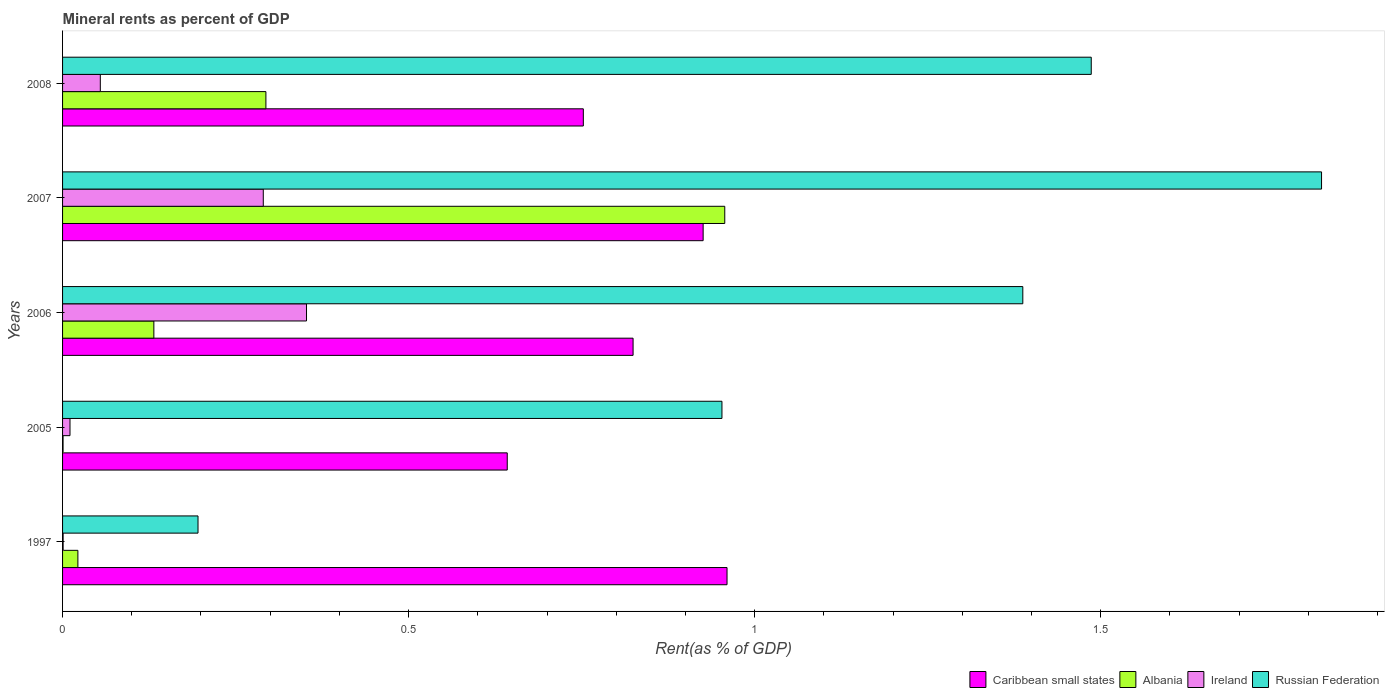How many different coloured bars are there?
Offer a very short reply. 4. How many groups of bars are there?
Give a very brief answer. 5. Are the number of bars per tick equal to the number of legend labels?
Provide a succinct answer. Yes. What is the mineral rent in Caribbean small states in 1997?
Offer a terse response. 0.96. Across all years, what is the maximum mineral rent in Ireland?
Offer a terse response. 0.35. Across all years, what is the minimum mineral rent in Albania?
Ensure brevity in your answer.  0. In which year was the mineral rent in Ireland minimum?
Make the answer very short. 1997. What is the total mineral rent in Caribbean small states in the graph?
Provide a succinct answer. 4.11. What is the difference between the mineral rent in Albania in 1997 and that in 2007?
Provide a short and direct response. -0.93. What is the difference between the mineral rent in Caribbean small states in 2006 and the mineral rent in Albania in 2007?
Make the answer very short. -0.13. What is the average mineral rent in Caribbean small states per year?
Provide a short and direct response. 0.82. In the year 2008, what is the difference between the mineral rent in Russian Federation and mineral rent in Albania?
Make the answer very short. 1.19. What is the ratio of the mineral rent in Ireland in 1997 to that in 2006?
Offer a very short reply. 0. Is the difference between the mineral rent in Russian Federation in 2005 and 2008 greater than the difference between the mineral rent in Albania in 2005 and 2008?
Provide a succinct answer. No. What is the difference between the highest and the second highest mineral rent in Albania?
Keep it short and to the point. 0.66. What is the difference between the highest and the lowest mineral rent in Albania?
Offer a terse response. 0.96. Is the sum of the mineral rent in Caribbean small states in 2005 and 2008 greater than the maximum mineral rent in Ireland across all years?
Your answer should be compact. Yes. Is it the case that in every year, the sum of the mineral rent in Russian Federation and mineral rent in Albania is greater than the sum of mineral rent in Caribbean small states and mineral rent in Ireland?
Offer a very short reply. No. What does the 4th bar from the top in 2008 represents?
Make the answer very short. Caribbean small states. What does the 4th bar from the bottom in 2007 represents?
Offer a very short reply. Russian Federation. What is the difference between two consecutive major ticks on the X-axis?
Ensure brevity in your answer.  0.5. How are the legend labels stacked?
Offer a terse response. Horizontal. What is the title of the graph?
Keep it short and to the point. Mineral rents as percent of GDP. What is the label or title of the X-axis?
Give a very brief answer. Rent(as % of GDP). What is the label or title of the Y-axis?
Your answer should be compact. Years. What is the Rent(as % of GDP) in Caribbean small states in 1997?
Your answer should be very brief. 0.96. What is the Rent(as % of GDP) of Albania in 1997?
Provide a short and direct response. 0.02. What is the Rent(as % of GDP) in Ireland in 1997?
Offer a terse response. 0. What is the Rent(as % of GDP) in Russian Federation in 1997?
Give a very brief answer. 0.2. What is the Rent(as % of GDP) in Caribbean small states in 2005?
Ensure brevity in your answer.  0.64. What is the Rent(as % of GDP) in Albania in 2005?
Offer a terse response. 0. What is the Rent(as % of GDP) in Ireland in 2005?
Your answer should be very brief. 0.01. What is the Rent(as % of GDP) of Russian Federation in 2005?
Your answer should be very brief. 0.95. What is the Rent(as % of GDP) in Caribbean small states in 2006?
Ensure brevity in your answer.  0.82. What is the Rent(as % of GDP) of Albania in 2006?
Provide a succinct answer. 0.13. What is the Rent(as % of GDP) of Ireland in 2006?
Your response must be concise. 0.35. What is the Rent(as % of GDP) in Russian Federation in 2006?
Your answer should be compact. 1.39. What is the Rent(as % of GDP) of Caribbean small states in 2007?
Provide a short and direct response. 0.93. What is the Rent(as % of GDP) in Albania in 2007?
Your answer should be compact. 0.96. What is the Rent(as % of GDP) of Ireland in 2007?
Your answer should be very brief. 0.29. What is the Rent(as % of GDP) in Russian Federation in 2007?
Your response must be concise. 1.82. What is the Rent(as % of GDP) in Caribbean small states in 2008?
Offer a very short reply. 0.75. What is the Rent(as % of GDP) in Albania in 2008?
Provide a succinct answer. 0.29. What is the Rent(as % of GDP) in Ireland in 2008?
Your answer should be compact. 0.05. What is the Rent(as % of GDP) of Russian Federation in 2008?
Your response must be concise. 1.49. Across all years, what is the maximum Rent(as % of GDP) of Caribbean small states?
Offer a terse response. 0.96. Across all years, what is the maximum Rent(as % of GDP) of Albania?
Your answer should be very brief. 0.96. Across all years, what is the maximum Rent(as % of GDP) of Ireland?
Give a very brief answer. 0.35. Across all years, what is the maximum Rent(as % of GDP) of Russian Federation?
Offer a terse response. 1.82. Across all years, what is the minimum Rent(as % of GDP) of Caribbean small states?
Make the answer very short. 0.64. Across all years, what is the minimum Rent(as % of GDP) in Albania?
Your answer should be very brief. 0. Across all years, what is the minimum Rent(as % of GDP) of Ireland?
Provide a succinct answer. 0. Across all years, what is the minimum Rent(as % of GDP) of Russian Federation?
Your answer should be very brief. 0.2. What is the total Rent(as % of GDP) of Caribbean small states in the graph?
Your response must be concise. 4.11. What is the total Rent(as % of GDP) of Albania in the graph?
Offer a very short reply. 1.41. What is the total Rent(as % of GDP) in Ireland in the graph?
Keep it short and to the point. 0.71. What is the total Rent(as % of GDP) of Russian Federation in the graph?
Give a very brief answer. 5.84. What is the difference between the Rent(as % of GDP) in Caribbean small states in 1997 and that in 2005?
Your response must be concise. 0.32. What is the difference between the Rent(as % of GDP) of Albania in 1997 and that in 2005?
Your answer should be very brief. 0.02. What is the difference between the Rent(as % of GDP) of Ireland in 1997 and that in 2005?
Give a very brief answer. -0.01. What is the difference between the Rent(as % of GDP) in Russian Federation in 1997 and that in 2005?
Offer a very short reply. -0.76. What is the difference between the Rent(as % of GDP) in Caribbean small states in 1997 and that in 2006?
Keep it short and to the point. 0.14. What is the difference between the Rent(as % of GDP) in Albania in 1997 and that in 2006?
Ensure brevity in your answer.  -0.11. What is the difference between the Rent(as % of GDP) in Ireland in 1997 and that in 2006?
Provide a succinct answer. -0.35. What is the difference between the Rent(as % of GDP) in Russian Federation in 1997 and that in 2006?
Make the answer very short. -1.19. What is the difference between the Rent(as % of GDP) of Caribbean small states in 1997 and that in 2007?
Make the answer very short. 0.03. What is the difference between the Rent(as % of GDP) in Albania in 1997 and that in 2007?
Keep it short and to the point. -0.93. What is the difference between the Rent(as % of GDP) in Ireland in 1997 and that in 2007?
Offer a terse response. -0.29. What is the difference between the Rent(as % of GDP) of Russian Federation in 1997 and that in 2007?
Make the answer very short. -1.62. What is the difference between the Rent(as % of GDP) in Caribbean small states in 1997 and that in 2008?
Ensure brevity in your answer.  0.21. What is the difference between the Rent(as % of GDP) in Albania in 1997 and that in 2008?
Make the answer very short. -0.27. What is the difference between the Rent(as % of GDP) of Ireland in 1997 and that in 2008?
Provide a short and direct response. -0.05. What is the difference between the Rent(as % of GDP) in Russian Federation in 1997 and that in 2008?
Ensure brevity in your answer.  -1.29. What is the difference between the Rent(as % of GDP) in Caribbean small states in 2005 and that in 2006?
Ensure brevity in your answer.  -0.18. What is the difference between the Rent(as % of GDP) in Albania in 2005 and that in 2006?
Your answer should be very brief. -0.13. What is the difference between the Rent(as % of GDP) in Ireland in 2005 and that in 2006?
Offer a terse response. -0.34. What is the difference between the Rent(as % of GDP) of Russian Federation in 2005 and that in 2006?
Ensure brevity in your answer.  -0.43. What is the difference between the Rent(as % of GDP) of Caribbean small states in 2005 and that in 2007?
Offer a terse response. -0.28. What is the difference between the Rent(as % of GDP) in Albania in 2005 and that in 2007?
Keep it short and to the point. -0.96. What is the difference between the Rent(as % of GDP) of Ireland in 2005 and that in 2007?
Provide a short and direct response. -0.28. What is the difference between the Rent(as % of GDP) of Russian Federation in 2005 and that in 2007?
Offer a very short reply. -0.87. What is the difference between the Rent(as % of GDP) of Caribbean small states in 2005 and that in 2008?
Provide a short and direct response. -0.11. What is the difference between the Rent(as % of GDP) in Albania in 2005 and that in 2008?
Make the answer very short. -0.29. What is the difference between the Rent(as % of GDP) in Ireland in 2005 and that in 2008?
Your response must be concise. -0.04. What is the difference between the Rent(as % of GDP) in Russian Federation in 2005 and that in 2008?
Make the answer very short. -0.53. What is the difference between the Rent(as % of GDP) in Caribbean small states in 2006 and that in 2007?
Offer a very short reply. -0.1. What is the difference between the Rent(as % of GDP) in Albania in 2006 and that in 2007?
Make the answer very short. -0.82. What is the difference between the Rent(as % of GDP) of Ireland in 2006 and that in 2007?
Your response must be concise. 0.06. What is the difference between the Rent(as % of GDP) of Russian Federation in 2006 and that in 2007?
Provide a succinct answer. -0.43. What is the difference between the Rent(as % of GDP) in Caribbean small states in 2006 and that in 2008?
Your response must be concise. 0.07. What is the difference between the Rent(as % of GDP) in Albania in 2006 and that in 2008?
Ensure brevity in your answer.  -0.16. What is the difference between the Rent(as % of GDP) in Ireland in 2006 and that in 2008?
Keep it short and to the point. 0.3. What is the difference between the Rent(as % of GDP) of Russian Federation in 2006 and that in 2008?
Offer a very short reply. -0.1. What is the difference between the Rent(as % of GDP) in Caribbean small states in 2007 and that in 2008?
Give a very brief answer. 0.17. What is the difference between the Rent(as % of GDP) of Albania in 2007 and that in 2008?
Your answer should be very brief. 0.66. What is the difference between the Rent(as % of GDP) of Ireland in 2007 and that in 2008?
Ensure brevity in your answer.  0.24. What is the difference between the Rent(as % of GDP) in Russian Federation in 2007 and that in 2008?
Your response must be concise. 0.33. What is the difference between the Rent(as % of GDP) in Caribbean small states in 1997 and the Rent(as % of GDP) in Albania in 2005?
Provide a succinct answer. 0.96. What is the difference between the Rent(as % of GDP) of Caribbean small states in 1997 and the Rent(as % of GDP) of Ireland in 2005?
Make the answer very short. 0.95. What is the difference between the Rent(as % of GDP) of Caribbean small states in 1997 and the Rent(as % of GDP) of Russian Federation in 2005?
Provide a succinct answer. 0.01. What is the difference between the Rent(as % of GDP) of Albania in 1997 and the Rent(as % of GDP) of Ireland in 2005?
Offer a very short reply. 0.01. What is the difference between the Rent(as % of GDP) in Albania in 1997 and the Rent(as % of GDP) in Russian Federation in 2005?
Your answer should be compact. -0.93. What is the difference between the Rent(as % of GDP) in Ireland in 1997 and the Rent(as % of GDP) in Russian Federation in 2005?
Offer a terse response. -0.95. What is the difference between the Rent(as % of GDP) of Caribbean small states in 1997 and the Rent(as % of GDP) of Albania in 2006?
Offer a terse response. 0.83. What is the difference between the Rent(as % of GDP) of Caribbean small states in 1997 and the Rent(as % of GDP) of Ireland in 2006?
Keep it short and to the point. 0.61. What is the difference between the Rent(as % of GDP) in Caribbean small states in 1997 and the Rent(as % of GDP) in Russian Federation in 2006?
Keep it short and to the point. -0.43. What is the difference between the Rent(as % of GDP) in Albania in 1997 and the Rent(as % of GDP) in Ireland in 2006?
Your answer should be compact. -0.33. What is the difference between the Rent(as % of GDP) of Albania in 1997 and the Rent(as % of GDP) of Russian Federation in 2006?
Offer a terse response. -1.37. What is the difference between the Rent(as % of GDP) of Ireland in 1997 and the Rent(as % of GDP) of Russian Federation in 2006?
Your answer should be very brief. -1.39. What is the difference between the Rent(as % of GDP) in Caribbean small states in 1997 and the Rent(as % of GDP) in Albania in 2007?
Provide a short and direct response. 0. What is the difference between the Rent(as % of GDP) of Caribbean small states in 1997 and the Rent(as % of GDP) of Ireland in 2007?
Your answer should be compact. 0.67. What is the difference between the Rent(as % of GDP) in Caribbean small states in 1997 and the Rent(as % of GDP) in Russian Federation in 2007?
Provide a short and direct response. -0.86. What is the difference between the Rent(as % of GDP) in Albania in 1997 and the Rent(as % of GDP) in Ireland in 2007?
Keep it short and to the point. -0.27. What is the difference between the Rent(as % of GDP) of Albania in 1997 and the Rent(as % of GDP) of Russian Federation in 2007?
Your answer should be compact. -1.8. What is the difference between the Rent(as % of GDP) in Ireland in 1997 and the Rent(as % of GDP) in Russian Federation in 2007?
Make the answer very short. -1.82. What is the difference between the Rent(as % of GDP) in Caribbean small states in 1997 and the Rent(as % of GDP) in Albania in 2008?
Keep it short and to the point. 0.67. What is the difference between the Rent(as % of GDP) of Caribbean small states in 1997 and the Rent(as % of GDP) of Ireland in 2008?
Make the answer very short. 0.91. What is the difference between the Rent(as % of GDP) in Caribbean small states in 1997 and the Rent(as % of GDP) in Russian Federation in 2008?
Give a very brief answer. -0.53. What is the difference between the Rent(as % of GDP) of Albania in 1997 and the Rent(as % of GDP) of Ireland in 2008?
Offer a terse response. -0.03. What is the difference between the Rent(as % of GDP) of Albania in 1997 and the Rent(as % of GDP) of Russian Federation in 2008?
Ensure brevity in your answer.  -1.46. What is the difference between the Rent(as % of GDP) of Ireland in 1997 and the Rent(as % of GDP) of Russian Federation in 2008?
Make the answer very short. -1.49. What is the difference between the Rent(as % of GDP) of Caribbean small states in 2005 and the Rent(as % of GDP) of Albania in 2006?
Ensure brevity in your answer.  0.51. What is the difference between the Rent(as % of GDP) of Caribbean small states in 2005 and the Rent(as % of GDP) of Ireland in 2006?
Offer a very short reply. 0.29. What is the difference between the Rent(as % of GDP) of Caribbean small states in 2005 and the Rent(as % of GDP) of Russian Federation in 2006?
Make the answer very short. -0.74. What is the difference between the Rent(as % of GDP) in Albania in 2005 and the Rent(as % of GDP) in Ireland in 2006?
Provide a short and direct response. -0.35. What is the difference between the Rent(as % of GDP) of Albania in 2005 and the Rent(as % of GDP) of Russian Federation in 2006?
Provide a succinct answer. -1.39. What is the difference between the Rent(as % of GDP) in Ireland in 2005 and the Rent(as % of GDP) in Russian Federation in 2006?
Give a very brief answer. -1.38. What is the difference between the Rent(as % of GDP) of Caribbean small states in 2005 and the Rent(as % of GDP) of Albania in 2007?
Provide a short and direct response. -0.31. What is the difference between the Rent(as % of GDP) in Caribbean small states in 2005 and the Rent(as % of GDP) in Ireland in 2007?
Keep it short and to the point. 0.35. What is the difference between the Rent(as % of GDP) of Caribbean small states in 2005 and the Rent(as % of GDP) of Russian Federation in 2007?
Provide a short and direct response. -1.18. What is the difference between the Rent(as % of GDP) in Albania in 2005 and the Rent(as % of GDP) in Ireland in 2007?
Offer a very short reply. -0.29. What is the difference between the Rent(as % of GDP) of Albania in 2005 and the Rent(as % of GDP) of Russian Federation in 2007?
Provide a succinct answer. -1.82. What is the difference between the Rent(as % of GDP) in Ireland in 2005 and the Rent(as % of GDP) in Russian Federation in 2007?
Ensure brevity in your answer.  -1.81. What is the difference between the Rent(as % of GDP) in Caribbean small states in 2005 and the Rent(as % of GDP) in Albania in 2008?
Ensure brevity in your answer.  0.35. What is the difference between the Rent(as % of GDP) of Caribbean small states in 2005 and the Rent(as % of GDP) of Ireland in 2008?
Make the answer very short. 0.59. What is the difference between the Rent(as % of GDP) of Caribbean small states in 2005 and the Rent(as % of GDP) of Russian Federation in 2008?
Provide a short and direct response. -0.84. What is the difference between the Rent(as % of GDP) in Albania in 2005 and the Rent(as % of GDP) in Ireland in 2008?
Offer a very short reply. -0.05. What is the difference between the Rent(as % of GDP) of Albania in 2005 and the Rent(as % of GDP) of Russian Federation in 2008?
Provide a succinct answer. -1.49. What is the difference between the Rent(as % of GDP) in Ireland in 2005 and the Rent(as % of GDP) in Russian Federation in 2008?
Keep it short and to the point. -1.48. What is the difference between the Rent(as % of GDP) of Caribbean small states in 2006 and the Rent(as % of GDP) of Albania in 2007?
Your answer should be compact. -0.13. What is the difference between the Rent(as % of GDP) of Caribbean small states in 2006 and the Rent(as % of GDP) of Ireland in 2007?
Offer a terse response. 0.53. What is the difference between the Rent(as % of GDP) of Caribbean small states in 2006 and the Rent(as % of GDP) of Russian Federation in 2007?
Offer a very short reply. -0.99. What is the difference between the Rent(as % of GDP) of Albania in 2006 and the Rent(as % of GDP) of Ireland in 2007?
Give a very brief answer. -0.16. What is the difference between the Rent(as % of GDP) of Albania in 2006 and the Rent(as % of GDP) of Russian Federation in 2007?
Make the answer very short. -1.69. What is the difference between the Rent(as % of GDP) in Ireland in 2006 and the Rent(as % of GDP) in Russian Federation in 2007?
Offer a very short reply. -1.47. What is the difference between the Rent(as % of GDP) of Caribbean small states in 2006 and the Rent(as % of GDP) of Albania in 2008?
Offer a very short reply. 0.53. What is the difference between the Rent(as % of GDP) in Caribbean small states in 2006 and the Rent(as % of GDP) in Ireland in 2008?
Your response must be concise. 0.77. What is the difference between the Rent(as % of GDP) in Caribbean small states in 2006 and the Rent(as % of GDP) in Russian Federation in 2008?
Make the answer very short. -0.66. What is the difference between the Rent(as % of GDP) of Albania in 2006 and the Rent(as % of GDP) of Ireland in 2008?
Provide a short and direct response. 0.08. What is the difference between the Rent(as % of GDP) in Albania in 2006 and the Rent(as % of GDP) in Russian Federation in 2008?
Provide a short and direct response. -1.35. What is the difference between the Rent(as % of GDP) of Ireland in 2006 and the Rent(as % of GDP) of Russian Federation in 2008?
Give a very brief answer. -1.13. What is the difference between the Rent(as % of GDP) of Caribbean small states in 2007 and the Rent(as % of GDP) of Albania in 2008?
Offer a very short reply. 0.63. What is the difference between the Rent(as % of GDP) in Caribbean small states in 2007 and the Rent(as % of GDP) in Ireland in 2008?
Give a very brief answer. 0.87. What is the difference between the Rent(as % of GDP) in Caribbean small states in 2007 and the Rent(as % of GDP) in Russian Federation in 2008?
Your response must be concise. -0.56. What is the difference between the Rent(as % of GDP) in Albania in 2007 and the Rent(as % of GDP) in Ireland in 2008?
Ensure brevity in your answer.  0.9. What is the difference between the Rent(as % of GDP) in Albania in 2007 and the Rent(as % of GDP) in Russian Federation in 2008?
Make the answer very short. -0.53. What is the difference between the Rent(as % of GDP) of Ireland in 2007 and the Rent(as % of GDP) of Russian Federation in 2008?
Your response must be concise. -1.2. What is the average Rent(as % of GDP) of Caribbean small states per year?
Keep it short and to the point. 0.82. What is the average Rent(as % of GDP) in Albania per year?
Keep it short and to the point. 0.28. What is the average Rent(as % of GDP) of Ireland per year?
Your answer should be very brief. 0.14. What is the average Rent(as % of GDP) of Russian Federation per year?
Your response must be concise. 1.17. In the year 1997, what is the difference between the Rent(as % of GDP) in Caribbean small states and Rent(as % of GDP) in Albania?
Keep it short and to the point. 0.94. In the year 1997, what is the difference between the Rent(as % of GDP) of Caribbean small states and Rent(as % of GDP) of Ireland?
Ensure brevity in your answer.  0.96. In the year 1997, what is the difference between the Rent(as % of GDP) in Caribbean small states and Rent(as % of GDP) in Russian Federation?
Your response must be concise. 0.76. In the year 1997, what is the difference between the Rent(as % of GDP) of Albania and Rent(as % of GDP) of Ireland?
Make the answer very short. 0.02. In the year 1997, what is the difference between the Rent(as % of GDP) in Albania and Rent(as % of GDP) in Russian Federation?
Your answer should be very brief. -0.17. In the year 1997, what is the difference between the Rent(as % of GDP) of Ireland and Rent(as % of GDP) of Russian Federation?
Give a very brief answer. -0.19. In the year 2005, what is the difference between the Rent(as % of GDP) of Caribbean small states and Rent(as % of GDP) of Albania?
Ensure brevity in your answer.  0.64. In the year 2005, what is the difference between the Rent(as % of GDP) in Caribbean small states and Rent(as % of GDP) in Ireland?
Keep it short and to the point. 0.63. In the year 2005, what is the difference between the Rent(as % of GDP) of Caribbean small states and Rent(as % of GDP) of Russian Federation?
Ensure brevity in your answer.  -0.31. In the year 2005, what is the difference between the Rent(as % of GDP) in Albania and Rent(as % of GDP) in Ireland?
Your answer should be very brief. -0.01. In the year 2005, what is the difference between the Rent(as % of GDP) of Albania and Rent(as % of GDP) of Russian Federation?
Your response must be concise. -0.95. In the year 2005, what is the difference between the Rent(as % of GDP) in Ireland and Rent(as % of GDP) in Russian Federation?
Your answer should be compact. -0.94. In the year 2006, what is the difference between the Rent(as % of GDP) of Caribbean small states and Rent(as % of GDP) of Albania?
Offer a terse response. 0.69. In the year 2006, what is the difference between the Rent(as % of GDP) of Caribbean small states and Rent(as % of GDP) of Ireland?
Provide a succinct answer. 0.47. In the year 2006, what is the difference between the Rent(as % of GDP) of Caribbean small states and Rent(as % of GDP) of Russian Federation?
Offer a very short reply. -0.56. In the year 2006, what is the difference between the Rent(as % of GDP) in Albania and Rent(as % of GDP) in Ireland?
Ensure brevity in your answer.  -0.22. In the year 2006, what is the difference between the Rent(as % of GDP) in Albania and Rent(as % of GDP) in Russian Federation?
Give a very brief answer. -1.26. In the year 2006, what is the difference between the Rent(as % of GDP) in Ireland and Rent(as % of GDP) in Russian Federation?
Give a very brief answer. -1.04. In the year 2007, what is the difference between the Rent(as % of GDP) of Caribbean small states and Rent(as % of GDP) of Albania?
Your answer should be very brief. -0.03. In the year 2007, what is the difference between the Rent(as % of GDP) in Caribbean small states and Rent(as % of GDP) in Ireland?
Your response must be concise. 0.64. In the year 2007, what is the difference between the Rent(as % of GDP) in Caribbean small states and Rent(as % of GDP) in Russian Federation?
Make the answer very short. -0.89. In the year 2007, what is the difference between the Rent(as % of GDP) in Albania and Rent(as % of GDP) in Ireland?
Offer a very short reply. 0.67. In the year 2007, what is the difference between the Rent(as % of GDP) of Albania and Rent(as % of GDP) of Russian Federation?
Your answer should be compact. -0.86. In the year 2007, what is the difference between the Rent(as % of GDP) in Ireland and Rent(as % of GDP) in Russian Federation?
Your response must be concise. -1.53. In the year 2008, what is the difference between the Rent(as % of GDP) of Caribbean small states and Rent(as % of GDP) of Albania?
Provide a short and direct response. 0.46. In the year 2008, what is the difference between the Rent(as % of GDP) of Caribbean small states and Rent(as % of GDP) of Ireland?
Provide a succinct answer. 0.7. In the year 2008, what is the difference between the Rent(as % of GDP) in Caribbean small states and Rent(as % of GDP) in Russian Federation?
Give a very brief answer. -0.73. In the year 2008, what is the difference between the Rent(as % of GDP) in Albania and Rent(as % of GDP) in Ireland?
Ensure brevity in your answer.  0.24. In the year 2008, what is the difference between the Rent(as % of GDP) in Albania and Rent(as % of GDP) in Russian Federation?
Give a very brief answer. -1.19. In the year 2008, what is the difference between the Rent(as % of GDP) in Ireland and Rent(as % of GDP) in Russian Federation?
Keep it short and to the point. -1.43. What is the ratio of the Rent(as % of GDP) in Caribbean small states in 1997 to that in 2005?
Your answer should be compact. 1.49. What is the ratio of the Rent(as % of GDP) in Albania in 1997 to that in 2005?
Make the answer very short. 31.11. What is the ratio of the Rent(as % of GDP) of Ireland in 1997 to that in 2005?
Ensure brevity in your answer.  0.07. What is the ratio of the Rent(as % of GDP) of Russian Federation in 1997 to that in 2005?
Give a very brief answer. 0.21. What is the ratio of the Rent(as % of GDP) of Caribbean small states in 1997 to that in 2006?
Offer a terse response. 1.16. What is the ratio of the Rent(as % of GDP) in Albania in 1997 to that in 2006?
Give a very brief answer. 0.17. What is the ratio of the Rent(as % of GDP) of Ireland in 1997 to that in 2006?
Keep it short and to the point. 0. What is the ratio of the Rent(as % of GDP) of Russian Federation in 1997 to that in 2006?
Provide a short and direct response. 0.14. What is the ratio of the Rent(as % of GDP) of Caribbean small states in 1997 to that in 2007?
Keep it short and to the point. 1.04. What is the ratio of the Rent(as % of GDP) in Albania in 1997 to that in 2007?
Your answer should be compact. 0.02. What is the ratio of the Rent(as % of GDP) in Ireland in 1997 to that in 2007?
Offer a very short reply. 0. What is the ratio of the Rent(as % of GDP) of Russian Federation in 1997 to that in 2007?
Offer a terse response. 0.11. What is the ratio of the Rent(as % of GDP) of Caribbean small states in 1997 to that in 2008?
Your response must be concise. 1.28. What is the ratio of the Rent(as % of GDP) in Albania in 1997 to that in 2008?
Give a very brief answer. 0.08. What is the ratio of the Rent(as % of GDP) of Ireland in 1997 to that in 2008?
Keep it short and to the point. 0.01. What is the ratio of the Rent(as % of GDP) in Russian Federation in 1997 to that in 2008?
Keep it short and to the point. 0.13. What is the ratio of the Rent(as % of GDP) in Caribbean small states in 2005 to that in 2006?
Your answer should be very brief. 0.78. What is the ratio of the Rent(as % of GDP) of Albania in 2005 to that in 2006?
Provide a succinct answer. 0.01. What is the ratio of the Rent(as % of GDP) in Ireland in 2005 to that in 2006?
Your answer should be very brief. 0.03. What is the ratio of the Rent(as % of GDP) in Russian Federation in 2005 to that in 2006?
Your response must be concise. 0.69. What is the ratio of the Rent(as % of GDP) in Caribbean small states in 2005 to that in 2007?
Offer a very short reply. 0.69. What is the ratio of the Rent(as % of GDP) in Albania in 2005 to that in 2007?
Your response must be concise. 0. What is the ratio of the Rent(as % of GDP) of Ireland in 2005 to that in 2007?
Keep it short and to the point. 0.04. What is the ratio of the Rent(as % of GDP) in Russian Federation in 2005 to that in 2007?
Your response must be concise. 0.52. What is the ratio of the Rent(as % of GDP) in Caribbean small states in 2005 to that in 2008?
Ensure brevity in your answer.  0.85. What is the ratio of the Rent(as % of GDP) of Albania in 2005 to that in 2008?
Keep it short and to the point. 0. What is the ratio of the Rent(as % of GDP) of Ireland in 2005 to that in 2008?
Offer a terse response. 0.2. What is the ratio of the Rent(as % of GDP) of Russian Federation in 2005 to that in 2008?
Your response must be concise. 0.64. What is the ratio of the Rent(as % of GDP) in Caribbean small states in 2006 to that in 2007?
Make the answer very short. 0.89. What is the ratio of the Rent(as % of GDP) in Albania in 2006 to that in 2007?
Offer a very short reply. 0.14. What is the ratio of the Rent(as % of GDP) of Ireland in 2006 to that in 2007?
Your response must be concise. 1.22. What is the ratio of the Rent(as % of GDP) of Russian Federation in 2006 to that in 2007?
Your response must be concise. 0.76. What is the ratio of the Rent(as % of GDP) of Caribbean small states in 2006 to that in 2008?
Give a very brief answer. 1.1. What is the ratio of the Rent(as % of GDP) of Albania in 2006 to that in 2008?
Offer a very short reply. 0.45. What is the ratio of the Rent(as % of GDP) of Ireland in 2006 to that in 2008?
Offer a very short reply. 6.46. What is the ratio of the Rent(as % of GDP) in Russian Federation in 2006 to that in 2008?
Ensure brevity in your answer.  0.93. What is the ratio of the Rent(as % of GDP) of Caribbean small states in 2007 to that in 2008?
Make the answer very short. 1.23. What is the ratio of the Rent(as % of GDP) of Albania in 2007 to that in 2008?
Ensure brevity in your answer.  3.26. What is the ratio of the Rent(as % of GDP) in Ireland in 2007 to that in 2008?
Your response must be concise. 5.32. What is the ratio of the Rent(as % of GDP) of Russian Federation in 2007 to that in 2008?
Your response must be concise. 1.22. What is the difference between the highest and the second highest Rent(as % of GDP) of Caribbean small states?
Give a very brief answer. 0.03. What is the difference between the highest and the second highest Rent(as % of GDP) of Albania?
Provide a short and direct response. 0.66. What is the difference between the highest and the second highest Rent(as % of GDP) in Ireland?
Offer a terse response. 0.06. What is the difference between the highest and the second highest Rent(as % of GDP) in Russian Federation?
Give a very brief answer. 0.33. What is the difference between the highest and the lowest Rent(as % of GDP) in Caribbean small states?
Ensure brevity in your answer.  0.32. What is the difference between the highest and the lowest Rent(as % of GDP) in Albania?
Make the answer very short. 0.96. What is the difference between the highest and the lowest Rent(as % of GDP) of Ireland?
Provide a succinct answer. 0.35. What is the difference between the highest and the lowest Rent(as % of GDP) in Russian Federation?
Offer a very short reply. 1.62. 